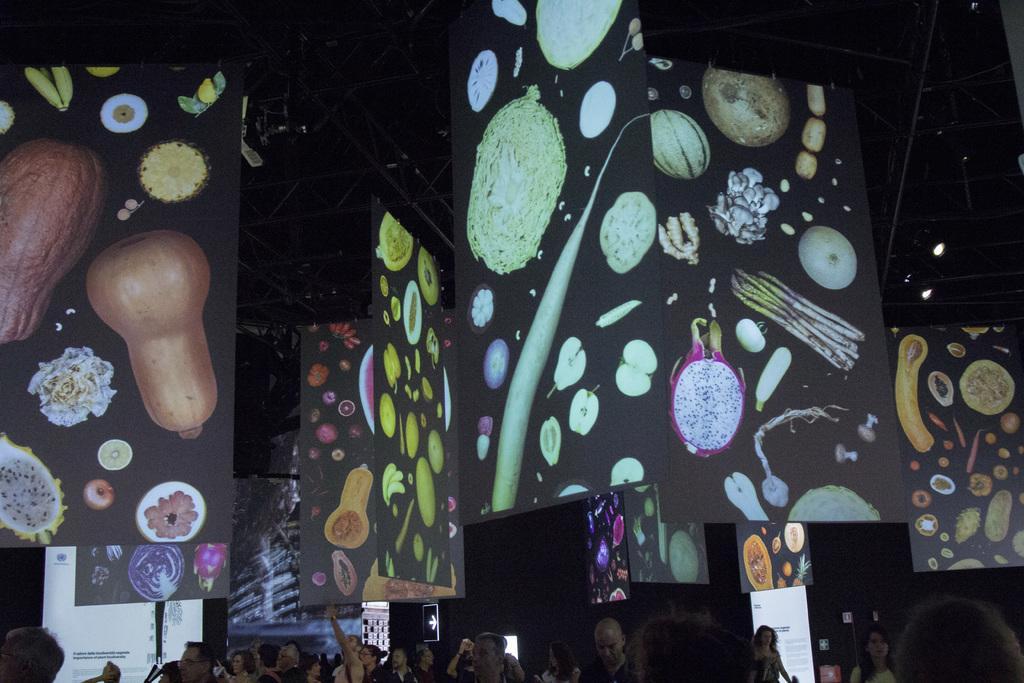Can you describe this image briefly? There are people and we can see boards. In the background it is dark. 